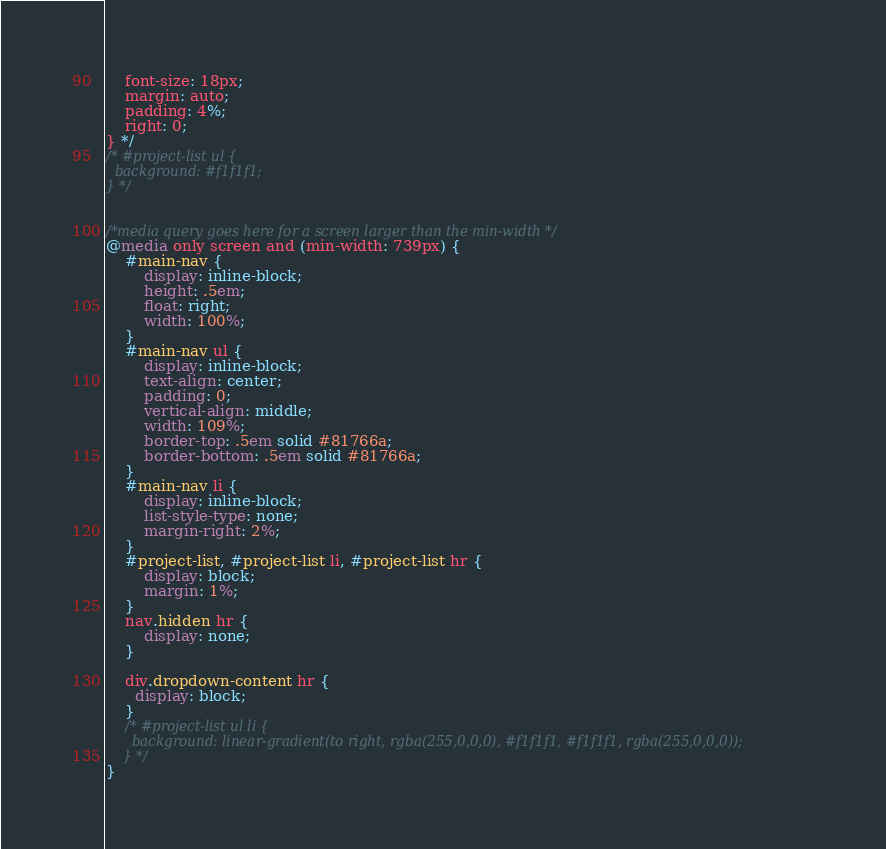Convert code to text. <code><loc_0><loc_0><loc_500><loc_500><_CSS_>    font-size: 18px;
    margin: auto;
    padding: 4%;
    right: 0;
} */
/* #project-list ul {
  background: #f1f1f1;
} */


/*media query goes here for a screen larger than the min-width */
@media only screen and (min-width: 739px) {
    #main-nav {
        display: inline-block;
        height: .5em;
        float: right;
        width: 100%;
    }
    #main-nav ul {
        display: inline-block;
        text-align: center;
        padding: 0;
        vertical-align: middle;
        width: 109%;
        border-top: .5em solid #81766a;
        border-bottom: .5em solid #81766a;
    }
    #main-nav li {
        display: inline-block;
        list-style-type: none;
        margin-right: 2%;
    }
    #project-list, #project-list li, #project-list hr {
        display: block;
        margin: 1%;
    }
    nav.hidden hr {
        display: none;
    }

    div.dropdown-content hr {
      display: block;
    }
    /* #project-list ul li {
      background: linear-gradient(to right, rgba(255,0,0,0), #f1f1f1, #f1f1f1, rgba(255,0,0,0));
    } */
}
</code> 